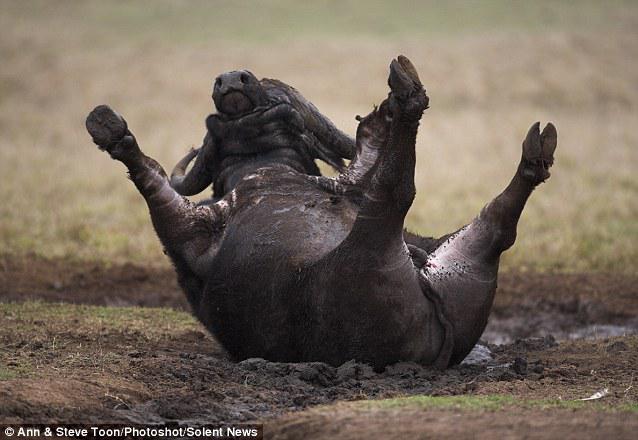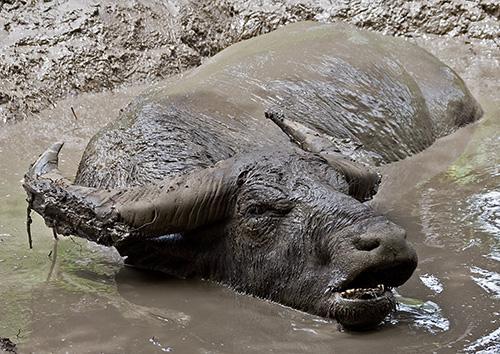The first image is the image on the left, the second image is the image on the right. Assess this claim about the two images: "All water buffalo are in mud that reaches at least to their chest, and no image contains more than three water buffalo.". Correct or not? Answer yes or no. No. The first image is the image on the left, the second image is the image on the right. Analyze the images presented: Is the assertion "The cow in each image is standing past their legs in the mud." valid? Answer yes or no. No. 